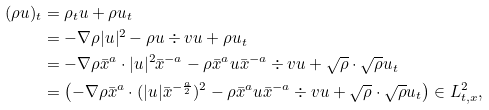<formula> <loc_0><loc_0><loc_500><loc_500>( \rho u ) _ { t } & = \rho _ { t } u + \rho u _ { t } \\ & = - \nabla \rho | u | ^ { 2 } - \rho u \div v u + \rho u _ { t } \\ & = - \nabla \rho \bar { x } ^ { a } \cdot | u | ^ { 2 } \bar { x } ^ { - a } - \rho \bar { x } ^ { a } u \bar { x } ^ { - a } \div v u + \sqrt { \rho } \cdot \sqrt { \rho } u _ { t } \\ & = \left ( - \nabla \rho \bar { x } ^ { a } \cdot ( | u | \bar { x } ^ { - \frac { a } { 2 } } ) ^ { 2 } - \rho \bar { x } ^ { a } u \bar { x } ^ { - a } \div v u + \sqrt { \rho } \cdot \sqrt { \rho } u _ { t } \right ) \in L _ { t , x } ^ { 2 } ,</formula> 